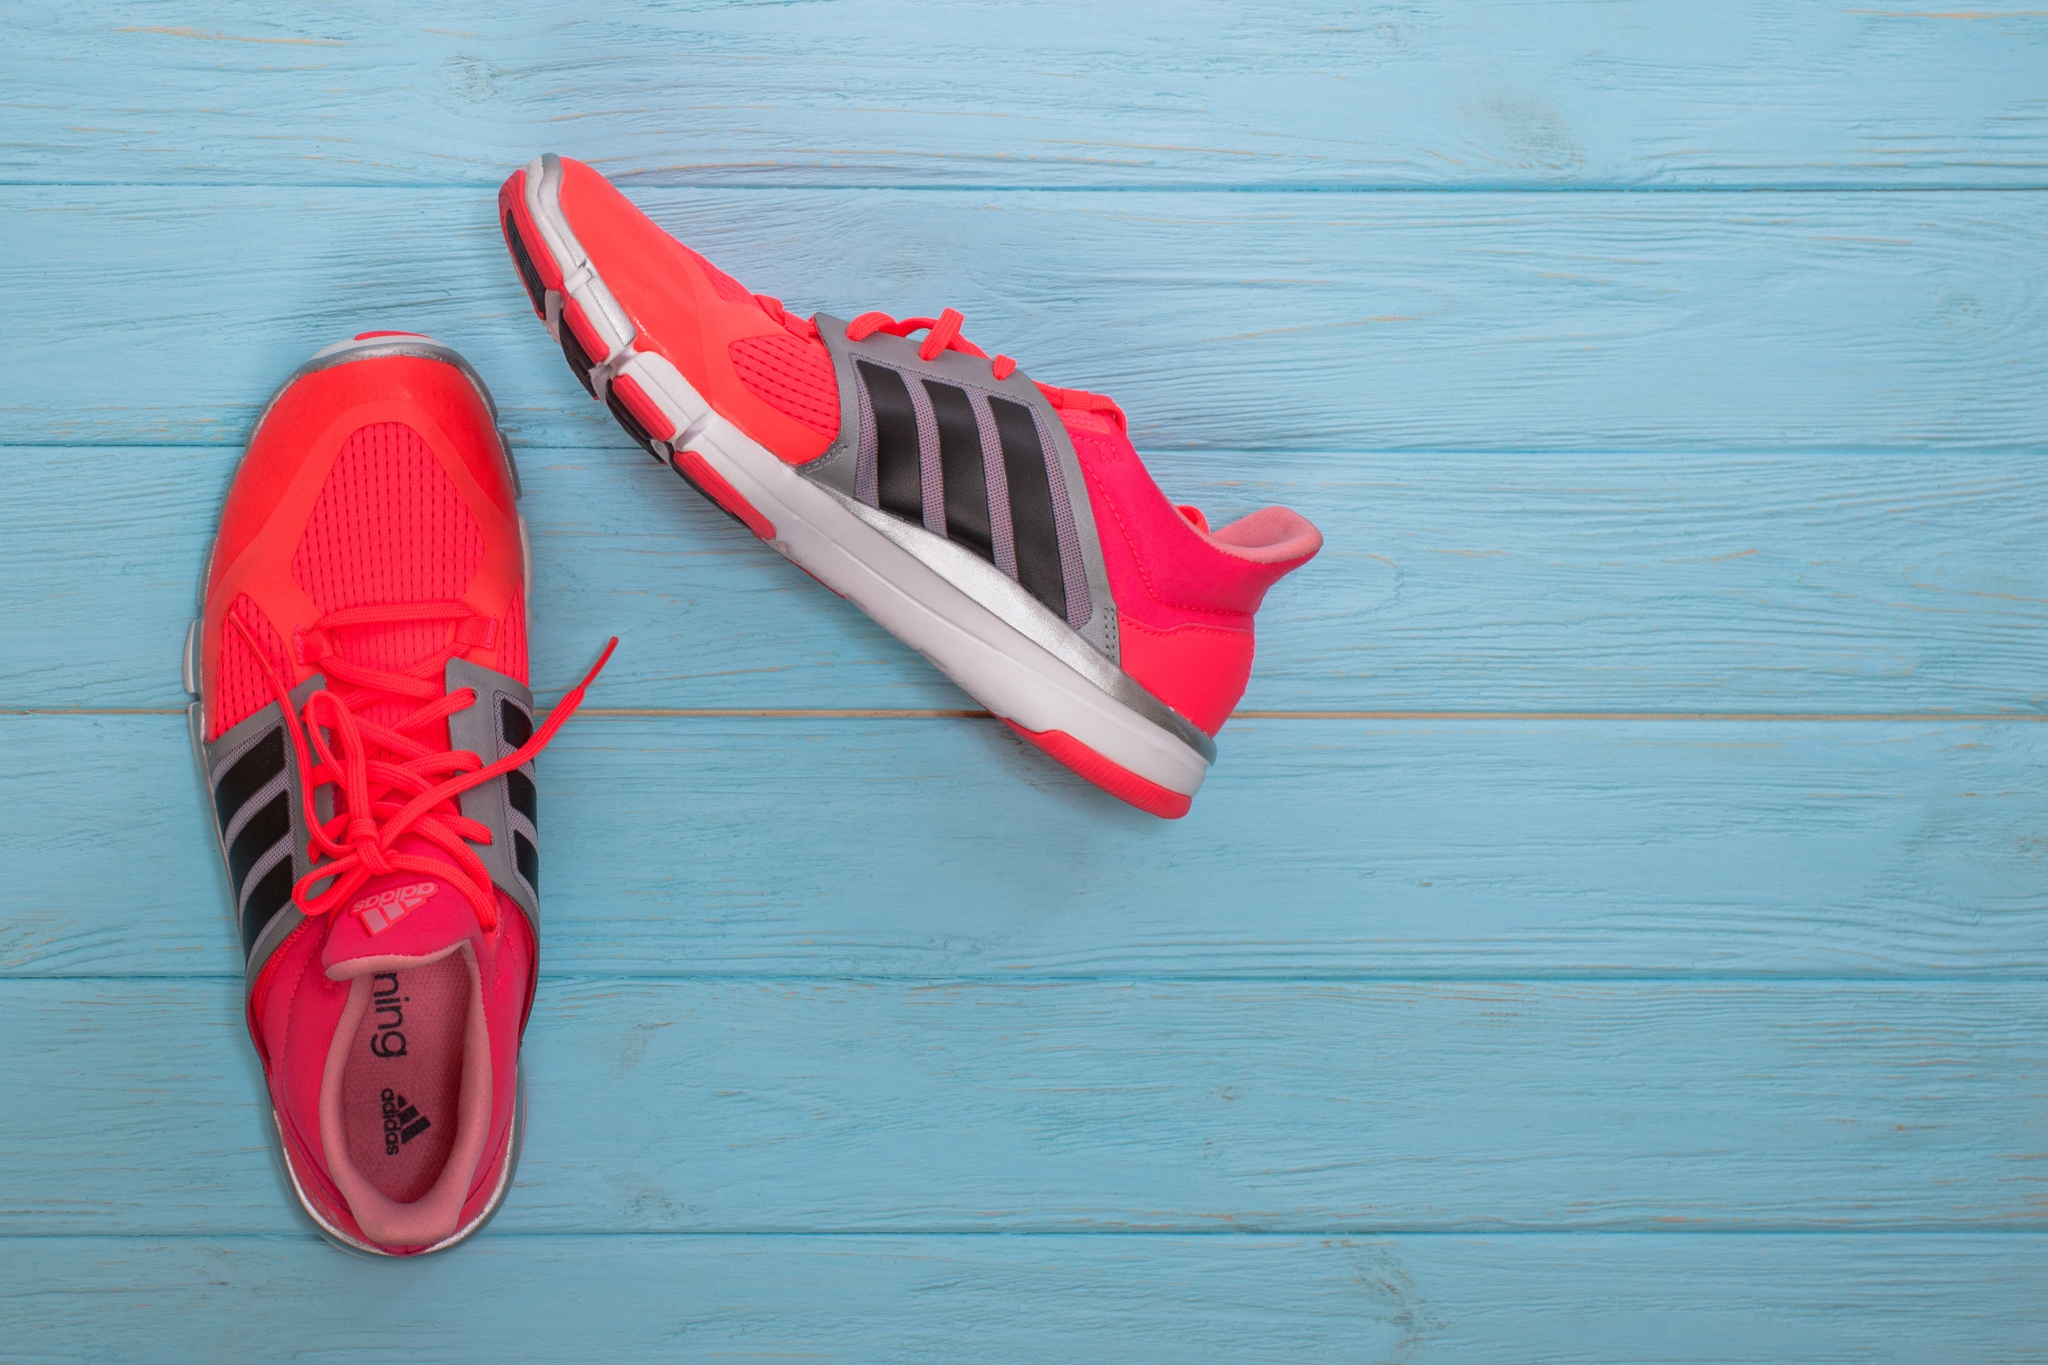Can you create a fun and imaginative story involving these shoes? Once upon a time, in the enchanted town of Soleville, there existed a pair of magical Adidas running shoes. These shoes weren't just any ordinary footwear; they had the power to transport their wearer to any desired destination in the blink of an eye. Bright red with mystic black stripes, they were created by an eccentric shoemaker who infused them with a drop of lightning and a dash of stardust. One day, a young adventurer named Max discovered the shoes hidden in an old chest in his grandmother's attic. Curious about their origin, Max laced them up and whispered, 'Take me to the highest mountain!' Instantly, he was whisked away to the peak of a majestic mountain, where he found himself amidst a flock of phoenixes. Max went on countless adventures with the shoes, from diving into the deepest oceans to dancing on the rings of Saturn. However, he soon realized that the true magic lay not in the places he visited, but in the incredible stories and friendships he forged along the way. In the end, Max decided to pass on the shoes to another dreamer, ensuring that the magic of the enchanted Adidas running shoes would continue to inspire and transport countless souls on their whimsical journeys. 